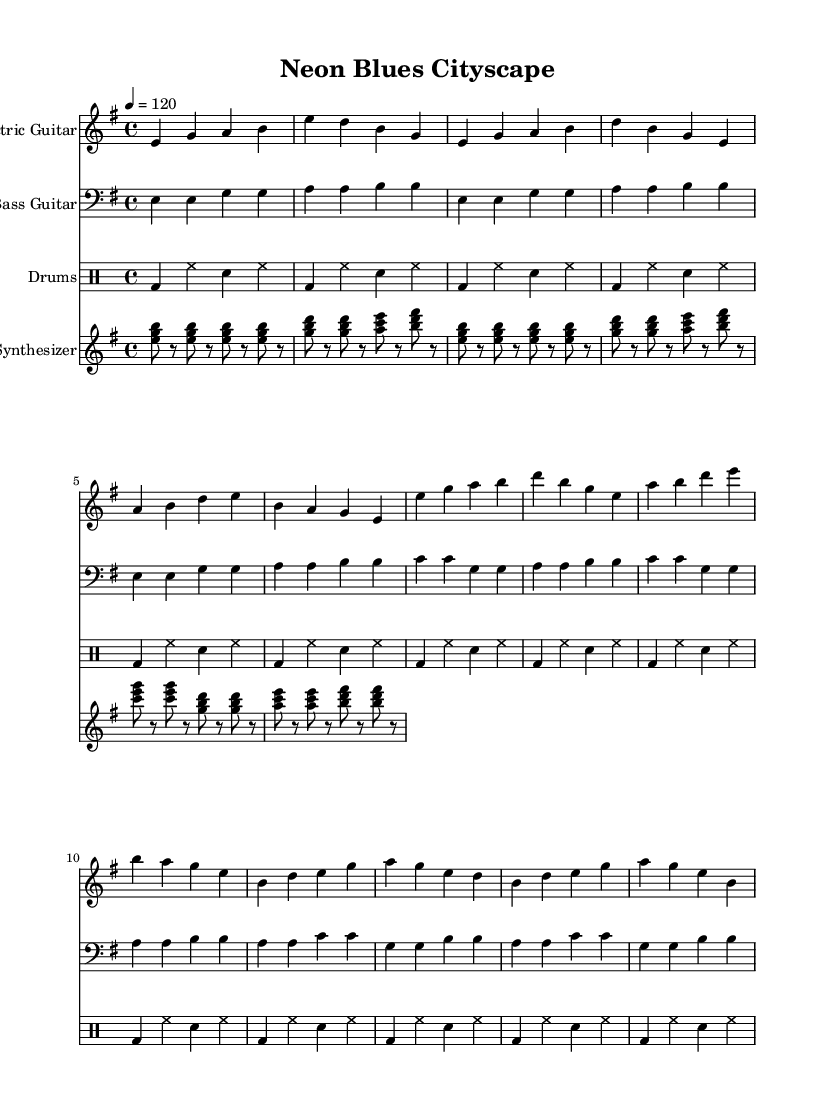What is the key signature of this music? The key signature is E minor, which has one sharp (F#). It can be found at the beginning of the sheet music.
Answer: E minor What is the time signature of this music? The time signature is 4/4, indicated at the start of the piece. This means there are four beats per measure.
Answer: 4/4 What is the tempo marking of this music? The tempo marking indicates a speed of 120 beats per minute, which can be seen written as "4 = 120" at the beginning of the score.
Answer: 120 How many sections are present in the music? The music consists of four sections: Intro, Verse, Chorus, and Bridge. Each section is distinct and contributes to the overall structure of the piece.
Answer: Four What instrument plays the bass line? The bass line is played by the Bass Guitar, which is indicated at the top of the corresponding staff in the sheet music.
Answer: Bass Guitar Which note is the first note in the electric guitar part? The first note in the electric guitar part is E, which is specified as "e" in the sheet music notation at the beginning of the electric guitar staff.
Answer: E How does the synthesizer contribute to the overall sound? The synthesizer supports the harmony by playing arpeggiated chords that complement the main melody, as noted in its respective staff. This adds depth to the sound and aligns with the urban and digital vibe of the piece.
Answer: Arpeggiated chords 